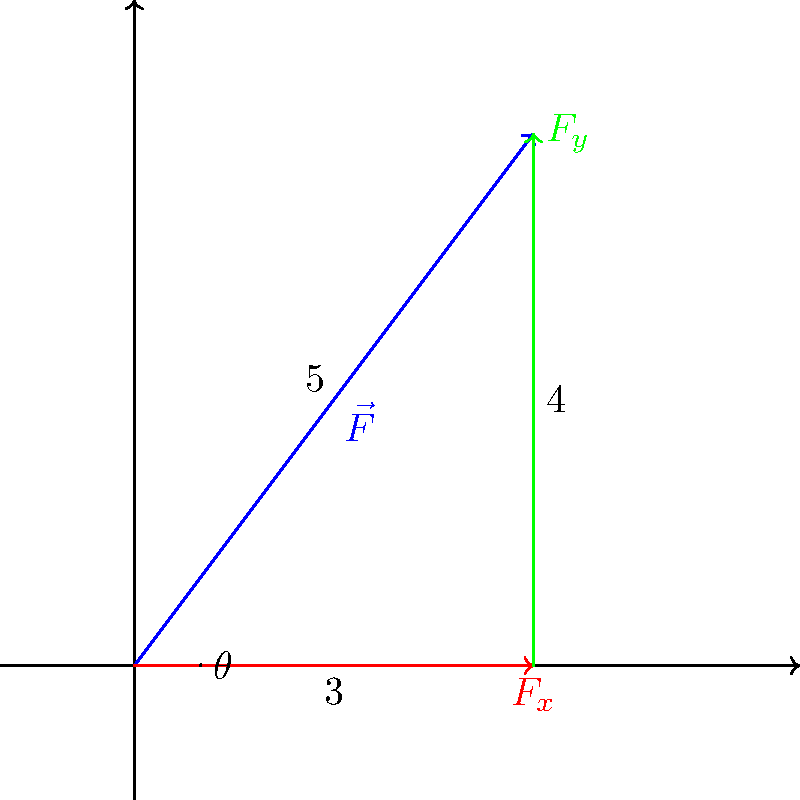A nurse is lifting a patient using proper body mechanics. The total force $\vec{F}$ applied has a magnitude of 5 units and makes an angle $\theta$ with the horizontal as shown in the diagram. What are the horizontal ($F_x$) and vertical ($F_y$) components of this force? To find the horizontal and vertical components of the force, we can use trigonometric relationships in the right triangle formed by the force vector and its components.

Step 1: Identify the known values
- The magnitude of the total force $|\vec{F}| = 5$ units
- The horizontal component $F_x = 3$ units (given in the diagram)
- The vertical component $F_y = 4$ units (given in the diagram)

Step 2: Verify the components using the Pythagorean theorem
$|\vec{F}|^2 = F_x^2 + F_y^2$
$5^2 = 3^2 + 4^2$
$25 = 9 + 16$
$25 = 25$ (verified)

Step 3: Calculate the angle $\theta$ (for completeness)
$\theta = \tan^{-1}(\frac{F_y}{F_x}) = \tan^{-1}(\frac{4}{3}) \approx 53.13°$

The horizontal component $F_x = 3$ units and the vertical component $F_y = 4$ units are correct and consistent with the given total force magnitude.
Answer: $F_x = 3$ units, $F_y = 4$ units 